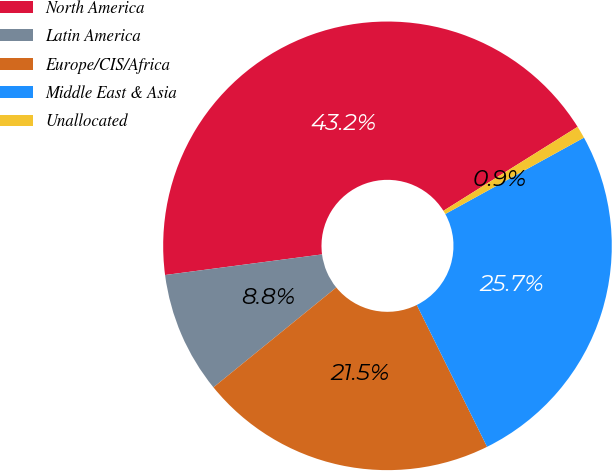<chart> <loc_0><loc_0><loc_500><loc_500><pie_chart><fcel>North America<fcel>Latin America<fcel>Europe/CIS/Africa<fcel>Middle East & Asia<fcel>Unallocated<nl><fcel>43.18%<fcel>8.79%<fcel>21.46%<fcel>25.69%<fcel>0.89%<nl></chart> 